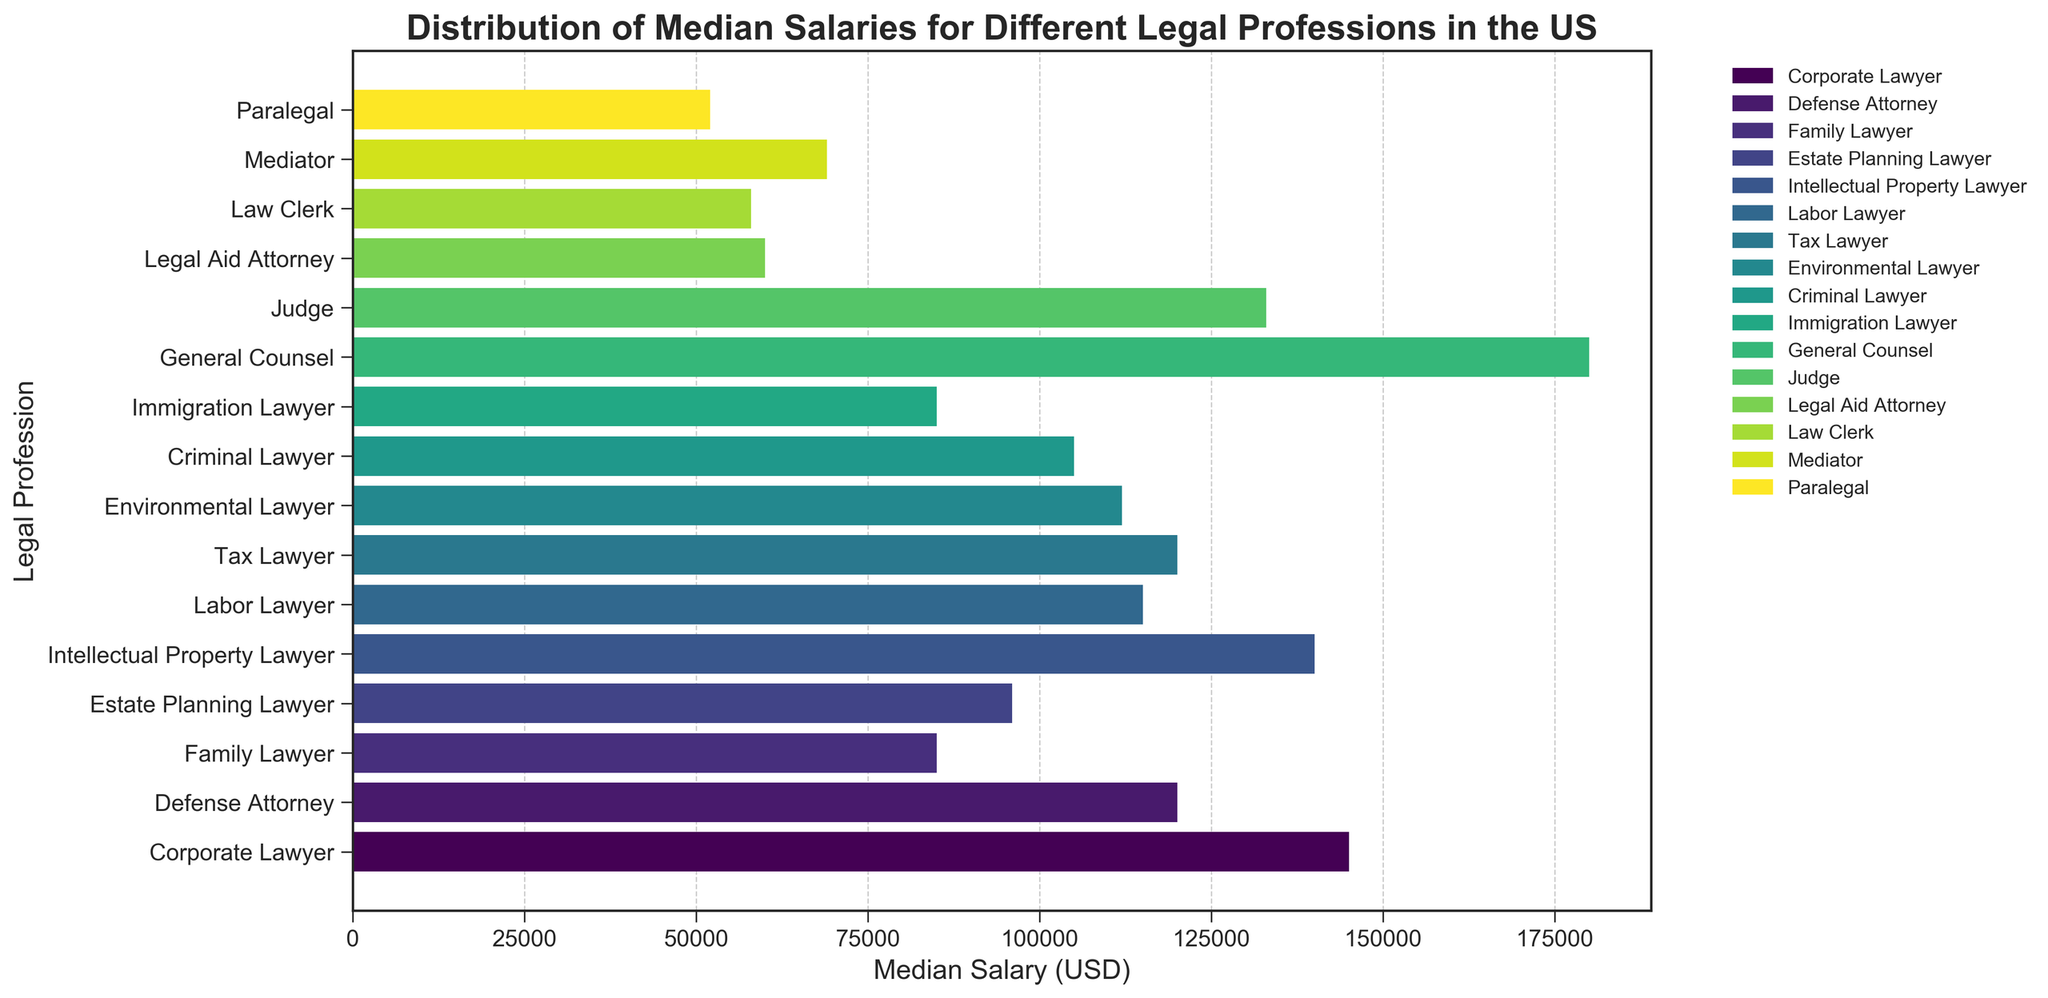What's the median salary difference between a Corporate Lawyer and a General Counsel? To find the difference in median salaries, we subtract the median salary of a Corporate Lawyer ($145,000) from the median salary of a General Counsel ($180,000). The calculation is $180,000 - $145,000.
Answer: $35,000 Which legal profession has the highest median salary, and what is that salary? By examining the bar heights, we identify the General Counsel as having the highest bar, indicating the highest median salary. The median salary for General Counsel is shown to be $180,000.
Answer: General Counsel, $180,000 Between a Mediator and an Environmental Lawyer, which position has a higher median salary and by how much? Comparing the bar heights of a Mediator ($69,000) and an Environmental Lawyer ($112,000), we see the Environmental Lawyer has a higher salary. Calculating the difference: $112,000 - $69,000.
Answer: Environmental Lawyer, $43,000 What is the combined median salary of a Paralegal, Law Clerk, and Legal Aid Attorney? Adding the median salaries of the three job titles: Paralegal ($52,000), Law Clerk ($58,000), and Legal Aid Attorney ($60,000). The total is $52,000 + $58,000 + $60,000.
Answer: $170,000 What is the median salary range (difference between highest and lowest) depicted in the chart? The highest median salary is for General Counsel ($180,000) and the lowest is for Paralegal ($52,000). Subtracting the lowest from the highest: $180,000 - $52,000.
Answer: $128,000 Is the median salary for a Defense Attorney higher or lower than a Tax Lawyer, and by how much? Comparing the bar heights, a Defense Attorney ($120,000) and a Tax Lawyer ($120,000) have the same median salary. Thus, the difference is $0.
Answer: Equal, $0 Which legal professions have median salaries below $100,000? Examining the bar chart, the professions with median salaries below $100,000 are Family Lawyer ($85,000), Estate Planning Lawyer ($96,000), Criminal Lawyer ($105,000), Immigration Lawyer ($85,000), Legal Aid Attorney ($60,000), Law Clerk ($58,000), Mediator ($69,000), and Paralegal ($52,000).
Answer: Family Lawyer, Estate Planning Lawyer, Criminal Lawyer, Immigration Lawyer, Legal Aid Attorney, Law Clerk, Mediator, Paralegal How does the median salary of an Intellectual Property Lawyer compare to that of a Judge? Comparing the bar heights, the median salary for an Intellectual Property Lawyer is $140,000, while a Judge has a median salary of $133,000. The Intellectual Property Lawyer has a higher median salary by $7,000.
Answer: Intellectual Property Lawyer, $7,000 What is the total median salary for all types of lawyers listed (excluding paralegals, mediators, judges, and clerks)? Summing the median salaries of Corporate Lawyer ($145,000), Defense Attorney ($120,000), Family Lawyer ($85,000), Estate Planning Lawyer ($96,000), Intellectual Property Lawyer ($140,000), Labor Lawyer ($115,000), Tax Lawyer ($120,000), Environmental Lawyer ($112,000), Criminal Lawyer ($105,000), and Immigration Lawyer ($85,000). The total is $1,123,000.
Answer: $1,123,000 